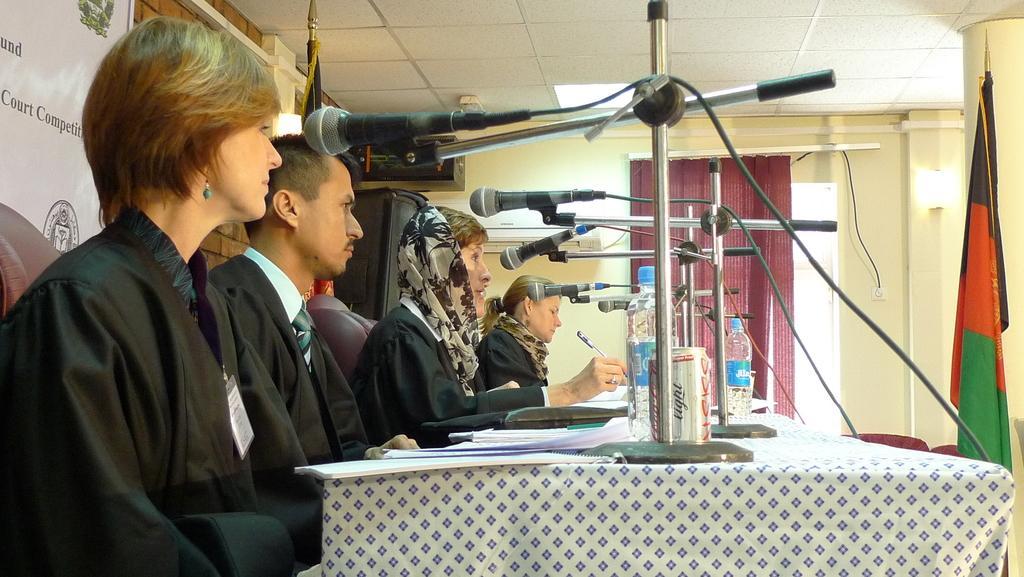How would you summarize this image in a sentence or two? In this image there are group of persons sitting. In the center there is a table, on the table there are mice, bottles, papers, and the woman sitting in the center is holding a pen in her hand. On the right side there is a flag which is in front of the table. In the background there is a curtain and on the wall there is a light. On the left side of the wall there is a banner with some text written on it and there are black colour objects. 